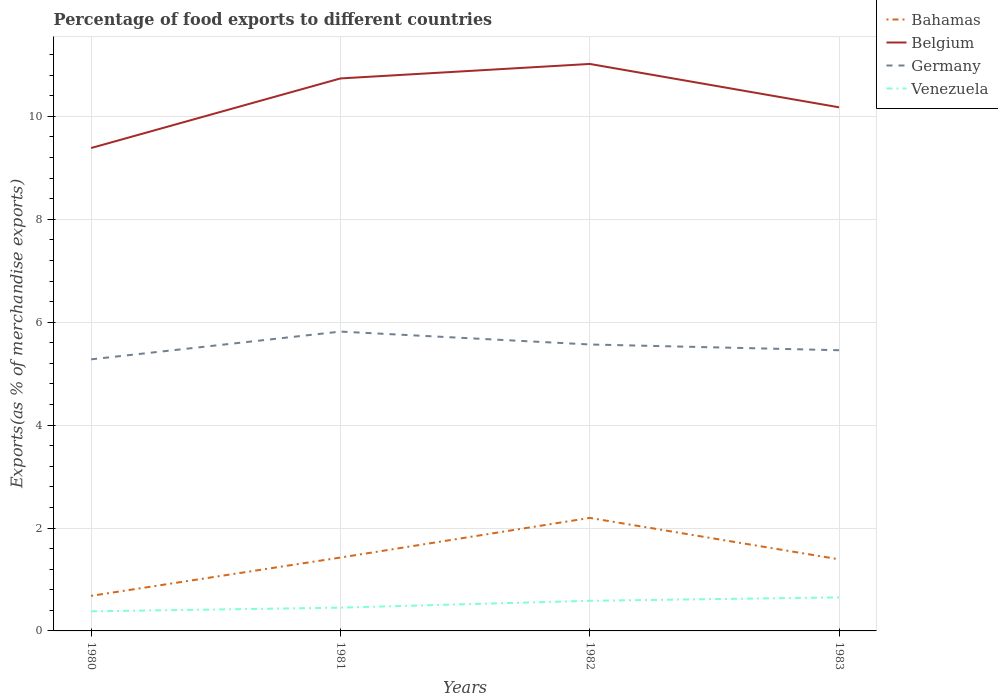Does the line corresponding to Germany intersect with the line corresponding to Bahamas?
Provide a succinct answer. No. Across all years, what is the maximum percentage of exports to different countries in Germany?
Provide a succinct answer. 5.28. What is the total percentage of exports to different countries in Venezuela in the graph?
Your answer should be compact. -0.07. What is the difference between the highest and the second highest percentage of exports to different countries in Bahamas?
Offer a terse response. 1.51. How many lines are there?
Provide a short and direct response. 4. How many years are there in the graph?
Your answer should be very brief. 4. Where does the legend appear in the graph?
Your answer should be very brief. Top right. How many legend labels are there?
Your response must be concise. 4. How are the legend labels stacked?
Make the answer very short. Vertical. What is the title of the graph?
Give a very brief answer. Percentage of food exports to different countries. Does "Jamaica" appear as one of the legend labels in the graph?
Provide a succinct answer. No. What is the label or title of the Y-axis?
Keep it short and to the point. Exports(as % of merchandise exports). What is the Exports(as % of merchandise exports) of Bahamas in 1980?
Ensure brevity in your answer.  0.68. What is the Exports(as % of merchandise exports) of Belgium in 1980?
Make the answer very short. 9.39. What is the Exports(as % of merchandise exports) of Germany in 1980?
Ensure brevity in your answer.  5.28. What is the Exports(as % of merchandise exports) in Venezuela in 1980?
Your response must be concise. 0.38. What is the Exports(as % of merchandise exports) in Bahamas in 1981?
Offer a terse response. 1.43. What is the Exports(as % of merchandise exports) of Belgium in 1981?
Offer a terse response. 10.74. What is the Exports(as % of merchandise exports) in Germany in 1981?
Your response must be concise. 5.82. What is the Exports(as % of merchandise exports) in Venezuela in 1981?
Offer a terse response. 0.45. What is the Exports(as % of merchandise exports) of Bahamas in 1982?
Your answer should be very brief. 2.2. What is the Exports(as % of merchandise exports) of Belgium in 1982?
Provide a succinct answer. 11.02. What is the Exports(as % of merchandise exports) of Germany in 1982?
Keep it short and to the point. 5.57. What is the Exports(as % of merchandise exports) in Venezuela in 1982?
Make the answer very short. 0.59. What is the Exports(as % of merchandise exports) in Bahamas in 1983?
Offer a terse response. 1.39. What is the Exports(as % of merchandise exports) in Belgium in 1983?
Keep it short and to the point. 10.18. What is the Exports(as % of merchandise exports) in Germany in 1983?
Offer a very short reply. 5.46. What is the Exports(as % of merchandise exports) of Venezuela in 1983?
Give a very brief answer. 0.65. Across all years, what is the maximum Exports(as % of merchandise exports) in Bahamas?
Ensure brevity in your answer.  2.2. Across all years, what is the maximum Exports(as % of merchandise exports) in Belgium?
Give a very brief answer. 11.02. Across all years, what is the maximum Exports(as % of merchandise exports) of Germany?
Make the answer very short. 5.82. Across all years, what is the maximum Exports(as % of merchandise exports) of Venezuela?
Your answer should be compact. 0.65. Across all years, what is the minimum Exports(as % of merchandise exports) of Bahamas?
Your response must be concise. 0.68. Across all years, what is the minimum Exports(as % of merchandise exports) of Belgium?
Your response must be concise. 9.39. Across all years, what is the minimum Exports(as % of merchandise exports) of Germany?
Your answer should be very brief. 5.28. Across all years, what is the minimum Exports(as % of merchandise exports) of Venezuela?
Give a very brief answer. 0.38. What is the total Exports(as % of merchandise exports) in Bahamas in the graph?
Give a very brief answer. 5.7. What is the total Exports(as % of merchandise exports) in Belgium in the graph?
Give a very brief answer. 41.32. What is the total Exports(as % of merchandise exports) of Germany in the graph?
Make the answer very short. 22.12. What is the total Exports(as % of merchandise exports) in Venezuela in the graph?
Provide a short and direct response. 2.07. What is the difference between the Exports(as % of merchandise exports) of Bahamas in 1980 and that in 1981?
Give a very brief answer. -0.74. What is the difference between the Exports(as % of merchandise exports) in Belgium in 1980 and that in 1981?
Provide a succinct answer. -1.35. What is the difference between the Exports(as % of merchandise exports) in Germany in 1980 and that in 1981?
Make the answer very short. -0.54. What is the difference between the Exports(as % of merchandise exports) of Venezuela in 1980 and that in 1981?
Offer a terse response. -0.07. What is the difference between the Exports(as % of merchandise exports) of Bahamas in 1980 and that in 1982?
Provide a succinct answer. -1.51. What is the difference between the Exports(as % of merchandise exports) of Belgium in 1980 and that in 1982?
Make the answer very short. -1.63. What is the difference between the Exports(as % of merchandise exports) of Germany in 1980 and that in 1982?
Ensure brevity in your answer.  -0.29. What is the difference between the Exports(as % of merchandise exports) of Venezuela in 1980 and that in 1982?
Offer a very short reply. -0.2. What is the difference between the Exports(as % of merchandise exports) in Bahamas in 1980 and that in 1983?
Provide a short and direct response. -0.71. What is the difference between the Exports(as % of merchandise exports) of Belgium in 1980 and that in 1983?
Provide a succinct answer. -0.79. What is the difference between the Exports(as % of merchandise exports) of Germany in 1980 and that in 1983?
Your answer should be compact. -0.18. What is the difference between the Exports(as % of merchandise exports) of Venezuela in 1980 and that in 1983?
Your answer should be very brief. -0.27. What is the difference between the Exports(as % of merchandise exports) in Bahamas in 1981 and that in 1982?
Your answer should be compact. -0.77. What is the difference between the Exports(as % of merchandise exports) in Belgium in 1981 and that in 1982?
Offer a terse response. -0.28. What is the difference between the Exports(as % of merchandise exports) of Germany in 1981 and that in 1982?
Give a very brief answer. 0.25. What is the difference between the Exports(as % of merchandise exports) in Venezuela in 1981 and that in 1982?
Keep it short and to the point. -0.13. What is the difference between the Exports(as % of merchandise exports) of Bahamas in 1981 and that in 1983?
Offer a terse response. 0.03. What is the difference between the Exports(as % of merchandise exports) of Belgium in 1981 and that in 1983?
Keep it short and to the point. 0.56. What is the difference between the Exports(as % of merchandise exports) in Germany in 1981 and that in 1983?
Your answer should be compact. 0.36. What is the difference between the Exports(as % of merchandise exports) of Venezuela in 1981 and that in 1983?
Provide a short and direct response. -0.2. What is the difference between the Exports(as % of merchandise exports) of Bahamas in 1982 and that in 1983?
Ensure brevity in your answer.  0.81. What is the difference between the Exports(as % of merchandise exports) of Belgium in 1982 and that in 1983?
Provide a short and direct response. 0.84. What is the difference between the Exports(as % of merchandise exports) of Germany in 1982 and that in 1983?
Keep it short and to the point. 0.11. What is the difference between the Exports(as % of merchandise exports) in Venezuela in 1982 and that in 1983?
Provide a short and direct response. -0.07. What is the difference between the Exports(as % of merchandise exports) in Bahamas in 1980 and the Exports(as % of merchandise exports) in Belgium in 1981?
Give a very brief answer. -10.06. What is the difference between the Exports(as % of merchandise exports) in Bahamas in 1980 and the Exports(as % of merchandise exports) in Germany in 1981?
Your response must be concise. -5.14. What is the difference between the Exports(as % of merchandise exports) in Bahamas in 1980 and the Exports(as % of merchandise exports) in Venezuela in 1981?
Your answer should be very brief. 0.23. What is the difference between the Exports(as % of merchandise exports) of Belgium in 1980 and the Exports(as % of merchandise exports) of Germany in 1981?
Ensure brevity in your answer.  3.57. What is the difference between the Exports(as % of merchandise exports) in Belgium in 1980 and the Exports(as % of merchandise exports) in Venezuela in 1981?
Provide a short and direct response. 8.93. What is the difference between the Exports(as % of merchandise exports) of Germany in 1980 and the Exports(as % of merchandise exports) of Venezuela in 1981?
Give a very brief answer. 4.83. What is the difference between the Exports(as % of merchandise exports) of Bahamas in 1980 and the Exports(as % of merchandise exports) of Belgium in 1982?
Offer a very short reply. -10.34. What is the difference between the Exports(as % of merchandise exports) in Bahamas in 1980 and the Exports(as % of merchandise exports) in Germany in 1982?
Provide a succinct answer. -4.89. What is the difference between the Exports(as % of merchandise exports) of Bahamas in 1980 and the Exports(as % of merchandise exports) of Venezuela in 1982?
Provide a short and direct response. 0.1. What is the difference between the Exports(as % of merchandise exports) in Belgium in 1980 and the Exports(as % of merchandise exports) in Germany in 1982?
Your answer should be very brief. 3.82. What is the difference between the Exports(as % of merchandise exports) in Belgium in 1980 and the Exports(as % of merchandise exports) in Venezuela in 1982?
Provide a short and direct response. 8.8. What is the difference between the Exports(as % of merchandise exports) of Germany in 1980 and the Exports(as % of merchandise exports) of Venezuela in 1982?
Make the answer very short. 4.69. What is the difference between the Exports(as % of merchandise exports) in Bahamas in 1980 and the Exports(as % of merchandise exports) in Belgium in 1983?
Offer a very short reply. -9.49. What is the difference between the Exports(as % of merchandise exports) in Bahamas in 1980 and the Exports(as % of merchandise exports) in Germany in 1983?
Ensure brevity in your answer.  -4.77. What is the difference between the Exports(as % of merchandise exports) of Bahamas in 1980 and the Exports(as % of merchandise exports) of Venezuela in 1983?
Your answer should be compact. 0.03. What is the difference between the Exports(as % of merchandise exports) in Belgium in 1980 and the Exports(as % of merchandise exports) in Germany in 1983?
Ensure brevity in your answer.  3.93. What is the difference between the Exports(as % of merchandise exports) in Belgium in 1980 and the Exports(as % of merchandise exports) in Venezuela in 1983?
Provide a short and direct response. 8.73. What is the difference between the Exports(as % of merchandise exports) of Germany in 1980 and the Exports(as % of merchandise exports) of Venezuela in 1983?
Give a very brief answer. 4.63. What is the difference between the Exports(as % of merchandise exports) of Bahamas in 1981 and the Exports(as % of merchandise exports) of Belgium in 1982?
Offer a terse response. -9.59. What is the difference between the Exports(as % of merchandise exports) in Bahamas in 1981 and the Exports(as % of merchandise exports) in Germany in 1982?
Your response must be concise. -4.14. What is the difference between the Exports(as % of merchandise exports) in Bahamas in 1981 and the Exports(as % of merchandise exports) in Venezuela in 1982?
Offer a terse response. 0.84. What is the difference between the Exports(as % of merchandise exports) in Belgium in 1981 and the Exports(as % of merchandise exports) in Germany in 1982?
Your answer should be very brief. 5.17. What is the difference between the Exports(as % of merchandise exports) in Belgium in 1981 and the Exports(as % of merchandise exports) in Venezuela in 1982?
Provide a succinct answer. 10.15. What is the difference between the Exports(as % of merchandise exports) of Germany in 1981 and the Exports(as % of merchandise exports) of Venezuela in 1982?
Your answer should be very brief. 5.23. What is the difference between the Exports(as % of merchandise exports) of Bahamas in 1981 and the Exports(as % of merchandise exports) of Belgium in 1983?
Your answer should be compact. -8.75. What is the difference between the Exports(as % of merchandise exports) in Bahamas in 1981 and the Exports(as % of merchandise exports) in Germany in 1983?
Provide a succinct answer. -4.03. What is the difference between the Exports(as % of merchandise exports) of Bahamas in 1981 and the Exports(as % of merchandise exports) of Venezuela in 1983?
Keep it short and to the point. 0.77. What is the difference between the Exports(as % of merchandise exports) of Belgium in 1981 and the Exports(as % of merchandise exports) of Germany in 1983?
Your answer should be compact. 5.28. What is the difference between the Exports(as % of merchandise exports) of Belgium in 1981 and the Exports(as % of merchandise exports) of Venezuela in 1983?
Your answer should be very brief. 10.09. What is the difference between the Exports(as % of merchandise exports) in Germany in 1981 and the Exports(as % of merchandise exports) in Venezuela in 1983?
Offer a terse response. 5.17. What is the difference between the Exports(as % of merchandise exports) in Bahamas in 1982 and the Exports(as % of merchandise exports) in Belgium in 1983?
Provide a short and direct response. -7.98. What is the difference between the Exports(as % of merchandise exports) of Bahamas in 1982 and the Exports(as % of merchandise exports) of Germany in 1983?
Keep it short and to the point. -3.26. What is the difference between the Exports(as % of merchandise exports) in Bahamas in 1982 and the Exports(as % of merchandise exports) in Venezuela in 1983?
Make the answer very short. 1.54. What is the difference between the Exports(as % of merchandise exports) of Belgium in 1982 and the Exports(as % of merchandise exports) of Germany in 1983?
Offer a very short reply. 5.56. What is the difference between the Exports(as % of merchandise exports) in Belgium in 1982 and the Exports(as % of merchandise exports) in Venezuela in 1983?
Provide a short and direct response. 10.37. What is the difference between the Exports(as % of merchandise exports) in Germany in 1982 and the Exports(as % of merchandise exports) in Venezuela in 1983?
Make the answer very short. 4.92. What is the average Exports(as % of merchandise exports) of Bahamas per year?
Your response must be concise. 1.42. What is the average Exports(as % of merchandise exports) in Belgium per year?
Provide a short and direct response. 10.33. What is the average Exports(as % of merchandise exports) in Germany per year?
Give a very brief answer. 5.53. What is the average Exports(as % of merchandise exports) of Venezuela per year?
Make the answer very short. 0.52. In the year 1980, what is the difference between the Exports(as % of merchandise exports) of Bahamas and Exports(as % of merchandise exports) of Belgium?
Provide a succinct answer. -8.7. In the year 1980, what is the difference between the Exports(as % of merchandise exports) in Bahamas and Exports(as % of merchandise exports) in Germany?
Provide a short and direct response. -4.6. In the year 1980, what is the difference between the Exports(as % of merchandise exports) of Bahamas and Exports(as % of merchandise exports) of Venezuela?
Ensure brevity in your answer.  0.3. In the year 1980, what is the difference between the Exports(as % of merchandise exports) of Belgium and Exports(as % of merchandise exports) of Germany?
Offer a terse response. 4.11. In the year 1980, what is the difference between the Exports(as % of merchandise exports) in Belgium and Exports(as % of merchandise exports) in Venezuela?
Your answer should be very brief. 9. In the year 1980, what is the difference between the Exports(as % of merchandise exports) in Germany and Exports(as % of merchandise exports) in Venezuela?
Offer a terse response. 4.9. In the year 1981, what is the difference between the Exports(as % of merchandise exports) of Bahamas and Exports(as % of merchandise exports) of Belgium?
Keep it short and to the point. -9.31. In the year 1981, what is the difference between the Exports(as % of merchandise exports) in Bahamas and Exports(as % of merchandise exports) in Germany?
Give a very brief answer. -4.39. In the year 1981, what is the difference between the Exports(as % of merchandise exports) of Bahamas and Exports(as % of merchandise exports) of Venezuela?
Ensure brevity in your answer.  0.97. In the year 1981, what is the difference between the Exports(as % of merchandise exports) of Belgium and Exports(as % of merchandise exports) of Germany?
Ensure brevity in your answer.  4.92. In the year 1981, what is the difference between the Exports(as % of merchandise exports) in Belgium and Exports(as % of merchandise exports) in Venezuela?
Give a very brief answer. 10.29. In the year 1981, what is the difference between the Exports(as % of merchandise exports) of Germany and Exports(as % of merchandise exports) of Venezuela?
Provide a succinct answer. 5.37. In the year 1982, what is the difference between the Exports(as % of merchandise exports) in Bahamas and Exports(as % of merchandise exports) in Belgium?
Provide a short and direct response. -8.82. In the year 1982, what is the difference between the Exports(as % of merchandise exports) of Bahamas and Exports(as % of merchandise exports) of Germany?
Give a very brief answer. -3.37. In the year 1982, what is the difference between the Exports(as % of merchandise exports) in Bahamas and Exports(as % of merchandise exports) in Venezuela?
Your answer should be compact. 1.61. In the year 1982, what is the difference between the Exports(as % of merchandise exports) of Belgium and Exports(as % of merchandise exports) of Germany?
Ensure brevity in your answer.  5.45. In the year 1982, what is the difference between the Exports(as % of merchandise exports) in Belgium and Exports(as % of merchandise exports) in Venezuela?
Offer a very short reply. 10.43. In the year 1982, what is the difference between the Exports(as % of merchandise exports) of Germany and Exports(as % of merchandise exports) of Venezuela?
Provide a succinct answer. 4.98. In the year 1983, what is the difference between the Exports(as % of merchandise exports) of Bahamas and Exports(as % of merchandise exports) of Belgium?
Your answer should be very brief. -8.78. In the year 1983, what is the difference between the Exports(as % of merchandise exports) of Bahamas and Exports(as % of merchandise exports) of Germany?
Your response must be concise. -4.06. In the year 1983, what is the difference between the Exports(as % of merchandise exports) in Bahamas and Exports(as % of merchandise exports) in Venezuela?
Your answer should be compact. 0.74. In the year 1983, what is the difference between the Exports(as % of merchandise exports) of Belgium and Exports(as % of merchandise exports) of Germany?
Make the answer very short. 4.72. In the year 1983, what is the difference between the Exports(as % of merchandise exports) of Belgium and Exports(as % of merchandise exports) of Venezuela?
Keep it short and to the point. 9.52. In the year 1983, what is the difference between the Exports(as % of merchandise exports) in Germany and Exports(as % of merchandise exports) in Venezuela?
Offer a very short reply. 4.8. What is the ratio of the Exports(as % of merchandise exports) in Bahamas in 1980 to that in 1981?
Ensure brevity in your answer.  0.48. What is the ratio of the Exports(as % of merchandise exports) of Belgium in 1980 to that in 1981?
Offer a terse response. 0.87. What is the ratio of the Exports(as % of merchandise exports) in Germany in 1980 to that in 1981?
Offer a very short reply. 0.91. What is the ratio of the Exports(as % of merchandise exports) of Venezuela in 1980 to that in 1981?
Your response must be concise. 0.84. What is the ratio of the Exports(as % of merchandise exports) of Bahamas in 1980 to that in 1982?
Offer a terse response. 0.31. What is the ratio of the Exports(as % of merchandise exports) in Belgium in 1980 to that in 1982?
Ensure brevity in your answer.  0.85. What is the ratio of the Exports(as % of merchandise exports) in Germany in 1980 to that in 1982?
Keep it short and to the point. 0.95. What is the ratio of the Exports(as % of merchandise exports) in Venezuela in 1980 to that in 1982?
Provide a short and direct response. 0.65. What is the ratio of the Exports(as % of merchandise exports) in Bahamas in 1980 to that in 1983?
Offer a very short reply. 0.49. What is the ratio of the Exports(as % of merchandise exports) in Belgium in 1980 to that in 1983?
Keep it short and to the point. 0.92. What is the ratio of the Exports(as % of merchandise exports) of Germany in 1980 to that in 1983?
Give a very brief answer. 0.97. What is the ratio of the Exports(as % of merchandise exports) in Venezuela in 1980 to that in 1983?
Keep it short and to the point. 0.58. What is the ratio of the Exports(as % of merchandise exports) in Bahamas in 1981 to that in 1982?
Provide a succinct answer. 0.65. What is the ratio of the Exports(as % of merchandise exports) in Belgium in 1981 to that in 1982?
Offer a very short reply. 0.97. What is the ratio of the Exports(as % of merchandise exports) in Germany in 1981 to that in 1982?
Provide a succinct answer. 1.04. What is the ratio of the Exports(as % of merchandise exports) in Venezuela in 1981 to that in 1982?
Give a very brief answer. 0.77. What is the ratio of the Exports(as % of merchandise exports) of Bahamas in 1981 to that in 1983?
Offer a very short reply. 1.02. What is the ratio of the Exports(as % of merchandise exports) of Belgium in 1981 to that in 1983?
Provide a short and direct response. 1.06. What is the ratio of the Exports(as % of merchandise exports) in Germany in 1981 to that in 1983?
Your answer should be compact. 1.07. What is the ratio of the Exports(as % of merchandise exports) in Venezuela in 1981 to that in 1983?
Your response must be concise. 0.69. What is the ratio of the Exports(as % of merchandise exports) of Bahamas in 1982 to that in 1983?
Keep it short and to the point. 1.58. What is the ratio of the Exports(as % of merchandise exports) of Belgium in 1982 to that in 1983?
Offer a very short reply. 1.08. What is the ratio of the Exports(as % of merchandise exports) of Germany in 1982 to that in 1983?
Offer a terse response. 1.02. What is the ratio of the Exports(as % of merchandise exports) of Venezuela in 1982 to that in 1983?
Your answer should be very brief. 0.9. What is the difference between the highest and the second highest Exports(as % of merchandise exports) of Bahamas?
Your response must be concise. 0.77. What is the difference between the highest and the second highest Exports(as % of merchandise exports) of Belgium?
Your response must be concise. 0.28. What is the difference between the highest and the second highest Exports(as % of merchandise exports) in Germany?
Provide a short and direct response. 0.25. What is the difference between the highest and the second highest Exports(as % of merchandise exports) in Venezuela?
Provide a succinct answer. 0.07. What is the difference between the highest and the lowest Exports(as % of merchandise exports) of Bahamas?
Give a very brief answer. 1.51. What is the difference between the highest and the lowest Exports(as % of merchandise exports) in Belgium?
Provide a succinct answer. 1.63. What is the difference between the highest and the lowest Exports(as % of merchandise exports) in Germany?
Keep it short and to the point. 0.54. What is the difference between the highest and the lowest Exports(as % of merchandise exports) in Venezuela?
Ensure brevity in your answer.  0.27. 